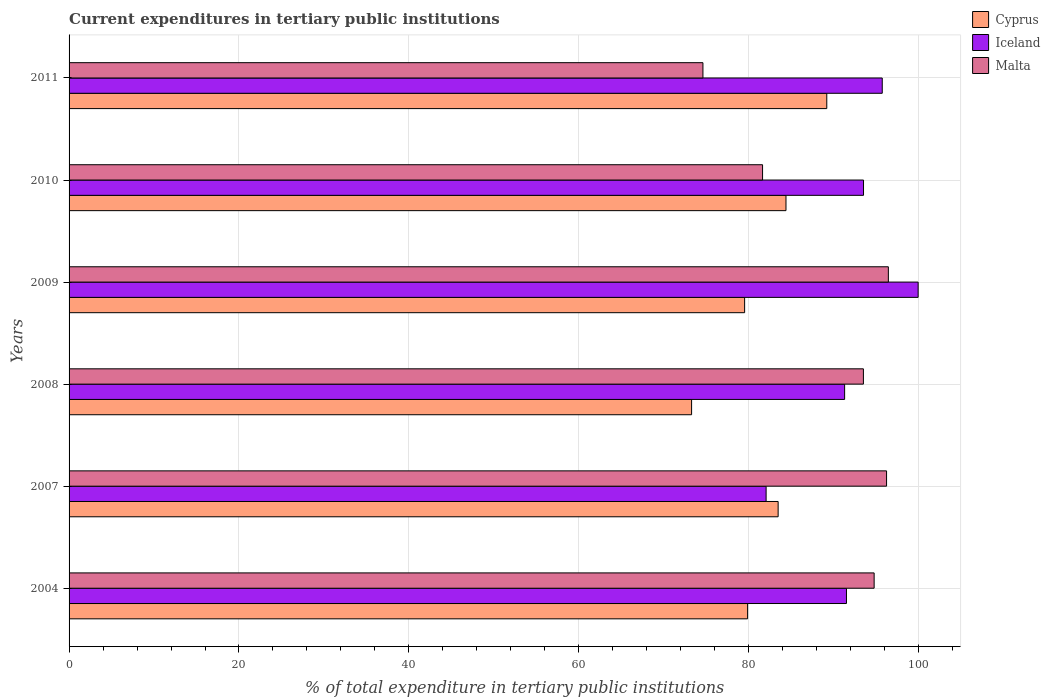How many different coloured bars are there?
Make the answer very short. 3. How many bars are there on the 1st tick from the top?
Give a very brief answer. 3. How many bars are there on the 1st tick from the bottom?
Provide a succinct answer. 3. What is the current expenditures in tertiary public institutions in Malta in 2011?
Provide a succinct answer. 74.62. Across all years, what is the maximum current expenditures in tertiary public institutions in Cyprus?
Keep it short and to the point. 89.19. Across all years, what is the minimum current expenditures in tertiary public institutions in Malta?
Provide a short and direct response. 74.62. In which year was the current expenditures in tertiary public institutions in Iceland minimum?
Make the answer very short. 2007. What is the total current expenditures in tertiary public institutions in Malta in the graph?
Provide a short and direct response. 537.19. What is the difference between the current expenditures in tertiary public institutions in Cyprus in 2008 and that in 2009?
Provide a succinct answer. -6.24. What is the difference between the current expenditures in tertiary public institutions in Malta in 2004 and the current expenditures in tertiary public institutions in Iceland in 2011?
Provide a short and direct response. -0.95. What is the average current expenditures in tertiary public institutions in Cyprus per year?
Your response must be concise. 81.62. In the year 2010, what is the difference between the current expenditures in tertiary public institutions in Malta and current expenditures in tertiary public institutions in Iceland?
Provide a succinct answer. -11.88. In how many years, is the current expenditures in tertiary public institutions in Cyprus greater than 72 %?
Provide a succinct answer. 6. What is the ratio of the current expenditures in tertiary public institutions in Malta in 2004 to that in 2011?
Give a very brief answer. 1.27. Is the difference between the current expenditures in tertiary public institutions in Malta in 2004 and 2008 greater than the difference between the current expenditures in tertiary public institutions in Iceland in 2004 and 2008?
Your answer should be compact. Yes. What is the difference between the highest and the second highest current expenditures in tertiary public institutions in Iceland?
Your answer should be very brief. 4.22. What is the difference between the highest and the lowest current expenditures in tertiary public institutions in Cyprus?
Offer a terse response. 15.91. Is the sum of the current expenditures in tertiary public institutions in Iceland in 2008 and 2011 greater than the maximum current expenditures in tertiary public institutions in Cyprus across all years?
Your response must be concise. Yes. What does the 3rd bar from the top in 2004 represents?
Provide a succinct answer. Cyprus. What does the 3rd bar from the bottom in 2008 represents?
Offer a terse response. Malta. Is it the case that in every year, the sum of the current expenditures in tertiary public institutions in Cyprus and current expenditures in tertiary public institutions in Malta is greater than the current expenditures in tertiary public institutions in Iceland?
Ensure brevity in your answer.  Yes. How many bars are there?
Provide a succinct answer. 18. Does the graph contain grids?
Keep it short and to the point. Yes. Where does the legend appear in the graph?
Offer a terse response. Top right. What is the title of the graph?
Your answer should be very brief. Current expenditures in tertiary public institutions. Does "Afghanistan" appear as one of the legend labels in the graph?
Provide a succinct answer. No. What is the label or title of the X-axis?
Make the answer very short. % of total expenditure in tertiary public institutions. What is the label or title of the Y-axis?
Provide a short and direct response. Years. What is the % of total expenditure in tertiary public institutions in Cyprus in 2004?
Your response must be concise. 79.87. What is the % of total expenditure in tertiary public institutions in Iceland in 2004?
Offer a very short reply. 91.51. What is the % of total expenditure in tertiary public institutions in Malta in 2004?
Ensure brevity in your answer.  94.77. What is the % of total expenditure in tertiary public institutions of Cyprus in 2007?
Your answer should be very brief. 83.47. What is the % of total expenditure in tertiary public institutions of Iceland in 2007?
Your answer should be very brief. 82.05. What is the % of total expenditure in tertiary public institutions of Malta in 2007?
Offer a terse response. 96.23. What is the % of total expenditure in tertiary public institutions of Cyprus in 2008?
Give a very brief answer. 73.28. What is the % of total expenditure in tertiary public institutions in Iceland in 2008?
Offer a terse response. 91.29. What is the % of total expenditure in tertiary public institutions of Malta in 2008?
Your response must be concise. 93.5. What is the % of total expenditure in tertiary public institutions of Cyprus in 2009?
Ensure brevity in your answer.  79.52. What is the % of total expenditure in tertiary public institutions in Iceland in 2009?
Provide a succinct answer. 99.95. What is the % of total expenditure in tertiary public institutions of Malta in 2009?
Your answer should be compact. 96.44. What is the % of total expenditure in tertiary public institutions in Cyprus in 2010?
Provide a short and direct response. 84.39. What is the % of total expenditure in tertiary public institutions of Iceland in 2010?
Ensure brevity in your answer.  93.52. What is the % of total expenditure in tertiary public institutions in Malta in 2010?
Your answer should be compact. 81.63. What is the % of total expenditure in tertiary public institutions of Cyprus in 2011?
Offer a terse response. 89.19. What is the % of total expenditure in tertiary public institutions of Iceland in 2011?
Provide a succinct answer. 95.72. What is the % of total expenditure in tertiary public institutions of Malta in 2011?
Keep it short and to the point. 74.62. Across all years, what is the maximum % of total expenditure in tertiary public institutions in Cyprus?
Make the answer very short. 89.19. Across all years, what is the maximum % of total expenditure in tertiary public institutions in Iceland?
Your answer should be compact. 99.95. Across all years, what is the maximum % of total expenditure in tertiary public institutions in Malta?
Offer a terse response. 96.44. Across all years, what is the minimum % of total expenditure in tertiary public institutions in Cyprus?
Offer a terse response. 73.28. Across all years, what is the minimum % of total expenditure in tertiary public institutions of Iceland?
Offer a terse response. 82.05. Across all years, what is the minimum % of total expenditure in tertiary public institutions in Malta?
Offer a terse response. 74.62. What is the total % of total expenditure in tertiary public institutions in Cyprus in the graph?
Keep it short and to the point. 489.72. What is the total % of total expenditure in tertiary public institutions in Iceland in the graph?
Keep it short and to the point. 554.04. What is the total % of total expenditure in tertiary public institutions in Malta in the graph?
Your answer should be very brief. 537.19. What is the difference between the % of total expenditure in tertiary public institutions of Cyprus in 2004 and that in 2007?
Your answer should be compact. -3.6. What is the difference between the % of total expenditure in tertiary public institutions of Iceland in 2004 and that in 2007?
Your response must be concise. 9.46. What is the difference between the % of total expenditure in tertiary public institutions in Malta in 2004 and that in 2007?
Give a very brief answer. -1.46. What is the difference between the % of total expenditure in tertiary public institutions of Cyprus in 2004 and that in 2008?
Offer a terse response. 6.59. What is the difference between the % of total expenditure in tertiary public institutions of Iceland in 2004 and that in 2008?
Give a very brief answer. 0.22. What is the difference between the % of total expenditure in tertiary public institutions of Malta in 2004 and that in 2008?
Give a very brief answer. 1.26. What is the difference between the % of total expenditure in tertiary public institutions in Cyprus in 2004 and that in 2009?
Your answer should be very brief. 0.35. What is the difference between the % of total expenditure in tertiary public institutions of Iceland in 2004 and that in 2009?
Your answer should be very brief. -8.44. What is the difference between the % of total expenditure in tertiary public institutions in Malta in 2004 and that in 2009?
Provide a short and direct response. -1.67. What is the difference between the % of total expenditure in tertiary public institutions in Cyprus in 2004 and that in 2010?
Keep it short and to the point. -4.52. What is the difference between the % of total expenditure in tertiary public institutions in Iceland in 2004 and that in 2010?
Give a very brief answer. -2.01. What is the difference between the % of total expenditure in tertiary public institutions in Malta in 2004 and that in 2010?
Your answer should be compact. 13.13. What is the difference between the % of total expenditure in tertiary public institutions of Cyprus in 2004 and that in 2011?
Provide a succinct answer. -9.32. What is the difference between the % of total expenditure in tertiary public institutions in Iceland in 2004 and that in 2011?
Provide a short and direct response. -4.21. What is the difference between the % of total expenditure in tertiary public institutions in Malta in 2004 and that in 2011?
Provide a short and direct response. 20.15. What is the difference between the % of total expenditure in tertiary public institutions of Cyprus in 2007 and that in 2008?
Ensure brevity in your answer.  10.19. What is the difference between the % of total expenditure in tertiary public institutions in Iceland in 2007 and that in 2008?
Your answer should be compact. -9.24. What is the difference between the % of total expenditure in tertiary public institutions in Malta in 2007 and that in 2008?
Your answer should be compact. 2.73. What is the difference between the % of total expenditure in tertiary public institutions of Cyprus in 2007 and that in 2009?
Offer a terse response. 3.95. What is the difference between the % of total expenditure in tertiary public institutions in Iceland in 2007 and that in 2009?
Your response must be concise. -17.89. What is the difference between the % of total expenditure in tertiary public institutions of Malta in 2007 and that in 2009?
Offer a very short reply. -0.21. What is the difference between the % of total expenditure in tertiary public institutions in Cyprus in 2007 and that in 2010?
Your answer should be compact. -0.92. What is the difference between the % of total expenditure in tertiary public institutions in Iceland in 2007 and that in 2010?
Keep it short and to the point. -11.47. What is the difference between the % of total expenditure in tertiary public institutions in Malta in 2007 and that in 2010?
Make the answer very short. 14.6. What is the difference between the % of total expenditure in tertiary public institutions in Cyprus in 2007 and that in 2011?
Keep it short and to the point. -5.73. What is the difference between the % of total expenditure in tertiary public institutions of Iceland in 2007 and that in 2011?
Your answer should be very brief. -13.67. What is the difference between the % of total expenditure in tertiary public institutions of Malta in 2007 and that in 2011?
Your answer should be very brief. 21.62. What is the difference between the % of total expenditure in tertiary public institutions of Cyprus in 2008 and that in 2009?
Give a very brief answer. -6.24. What is the difference between the % of total expenditure in tertiary public institutions of Iceland in 2008 and that in 2009?
Give a very brief answer. -8.65. What is the difference between the % of total expenditure in tertiary public institutions in Malta in 2008 and that in 2009?
Offer a terse response. -2.94. What is the difference between the % of total expenditure in tertiary public institutions of Cyprus in 2008 and that in 2010?
Make the answer very short. -11.11. What is the difference between the % of total expenditure in tertiary public institutions in Iceland in 2008 and that in 2010?
Ensure brevity in your answer.  -2.22. What is the difference between the % of total expenditure in tertiary public institutions in Malta in 2008 and that in 2010?
Your answer should be very brief. 11.87. What is the difference between the % of total expenditure in tertiary public institutions of Cyprus in 2008 and that in 2011?
Offer a terse response. -15.91. What is the difference between the % of total expenditure in tertiary public institutions of Iceland in 2008 and that in 2011?
Ensure brevity in your answer.  -4.43. What is the difference between the % of total expenditure in tertiary public institutions in Malta in 2008 and that in 2011?
Your answer should be very brief. 18.89. What is the difference between the % of total expenditure in tertiary public institutions in Cyprus in 2009 and that in 2010?
Ensure brevity in your answer.  -4.87. What is the difference between the % of total expenditure in tertiary public institutions in Iceland in 2009 and that in 2010?
Your response must be concise. 6.43. What is the difference between the % of total expenditure in tertiary public institutions of Malta in 2009 and that in 2010?
Give a very brief answer. 14.81. What is the difference between the % of total expenditure in tertiary public institutions in Cyprus in 2009 and that in 2011?
Give a very brief answer. -9.67. What is the difference between the % of total expenditure in tertiary public institutions of Iceland in 2009 and that in 2011?
Your answer should be very brief. 4.22. What is the difference between the % of total expenditure in tertiary public institutions of Malta in 2009 and that in 2011?
Keep it short and to the point. 21.83. What is the difference between the % of total expenditure in tertiary public institutions of Cyprus in 2010 and that in 2011?
Offer a terse response. -4.8. What is the difference between the % of total expenditure in tertiary public institutions in Iceland in 2010 and that in 2011?
Provide a succinct answer. -2.21. What is the difference between the % of total expenditure in tertiary public institutions of Malta in 2010 and that in 2011?
Make the answer very short. 7.02. What is the difference between the % of total expenditure in tertiary public institutions in Cyprus in 2004 and the % of total expenditure in tertiary public institutions in Iceland in 2007?
Your response must be concise. -2.18. What is the difference between the % of total expenditure in tertiary public institutions of Cyprus in 2004 and the % of total expenditure in tertiary public institutions of Malta in 2007?
Offer a terse response. -16.36. What is the difference between the % of total expenditure in tertiary public institutions of Iceland in 2004 and the % of total expenditure in tertiary public institutions of Malta in 2007?
Ensure brevity in your answer.  -4.72. What is the difference between the % of total expenditure in tertiary public institutions in Cyprus in 2004 and the % of total expenditure in tertiary public institutions in Iceland in 2008?
Your response must be concise. -11.42. What is the difference between the % of total expenditure in tertiary public institutions in Cyprus in 2004 and the % of total expenditure in tertiary public institutions in Malta in 2008?
Your answer should be very brief. -13.63. What is the difference between the % of total expenditure in tertiary public institutions of Iceland in 2004 and the % of total expenditure in tertiary public institutions of Malta in 2008?
Your answer should be very brief. -1.99. What is the difference between the % of total expenditure in tertiary public institutions of Cyprus in 2004 and the % of total expenditure in tertiary public institutions of Iceland in 2009?
Keep it short and to the point. -20.07. What is the difference between the % of total expenditure in tertiary public institutions of Cyprus in 2004 and the % of total expenditure in tertiary public institutions of Malta in 2009?
Offer a terse response. -16.57. What is the difference between the % of total expenditure in tertiary public institutions of Iceland in 2004 and the % of total expenditure in tertiary public institutions of Malta in 2009?
Your answer should be compact. -4.93. What is the difference between the % of total expenditure in tertiary public institutions of Cyprus in 2004 and the % of total expenditure in tertiary public institutions of Iceland in 2010?
Your answer should be compact. -13.65. What is the difference between the % of total expenditure in tertiary public institutions in Cyprus in 2004 and the % of total expenditure in tertiary public institutions in Malta in 2010?
Give a very brief answer. -1.76. What is the difference between the % of total expenditure in tertiary public institutions in Iceland in 2004 and the % of total expenditure in tertiary public institutions in Malta in 2010?
Offer a very short reply. 9.88. What is the difference between the % of total expenditure in tertiary public institutions of Cyprus in 2004 and the % of total expenditure in tertiary public institutions of Iceland in 2011?
Offer a very short reply. -15.85. What is the difference between the % of total expenditure in tertiary public institutions in Cyprus in 2004 and the % of total expenditure in tertiary public institutions in Malta in 2011?
Your response must be concise. 5.26. What is the difference between the % of total expenditure in tertiary public institutions of Iceland in 2004 and the % of total expenditure in tertiary public institutions of Malta in 2011?
Offer a terse response. 16.9. What is the difference between the % of total expenditure in tertiary public institutions in Cyprus in 2007 and the % of total expenditure in tertiary public institutions in Iceland in 2008?
Your response must be concise. -7.83. What is the difference between the % of total expenditure in tertiary public institutions of Cyprus in 2007 and the % of total expenditure in tertiary public institutions of Malta in 2008?
Your response must be concise. -10.04. What is the difference between the % of total expenditure in tertiary public institutions in Iceland in 2007 and the % of total expenditure in tertiary public institutions in Malta in 2008?
Ensure brevity in your answer.  -11.45. What is the difference between the % of total expenditure in tertiary public institutions of Cyprus in 2007 and the % of total expenditure in tertiary public institutions of Iceland in 2009?
Provide a short and direct response. -16.48. What is the difference between the % of total expenditure in tertiary public institutions of Cyprus in 2007 and the % of total expenditure in tertiary public institutions of Malta in 2009?
Provide a short and direct response. -12.97. What is the difference between the % of total expenditure in tertiary public institutions in Iceland in 2007 and the % of total expenditure in tertiary public institutions in Malta in 2009?
Keep it short and to the point. -14.39. What is the difference between the % of total expenditure in tertiary public institutions of Cyprus in 2007 and the % of total expenditure in tertiary public institutions of Iceland in 2010?
Provide a succinct answer. -10.05. What is the difference between the % of total expenditure in tertiary public institutions of Cyprus in 2007 and the % of total expenditure in tertiary public institutions of Malta in 2010?
Your response must be concise. 1.83. What is the difference between the % of total expenditure in tertiary public institutions of Iceland in 2007 and the % of total expenditure in tertiary public institutions of Malta in 2010?
Give a very brief answer. 0.42. What is the difference between the % of total expenditure in tertiary public institutions of Cyprus in 2007 and the % of total expenditure in tertiary public institutions of Iceland in 2011?
Make the answer very short. -12.25. What is the difference between the % of total expenditure in tertiary public institutions of Cyprus in 2007 and the % of total expenditure in tertiary public institutions of Malta in 2011?
Keep it short and to the point. 8.85. What is the difference between the % of total expenditure in tertiary public institutions in Iceland in 2007 and the % of total expenditure in tertiary public institutions in Malta in 2011?
Make the answer very short. 7.44. What is the difference between the % of total expenditure in tertiary public institutions of Cyprus in 2008 and the % of total expenditure in tertiary public institutions of Iceland in 2009?
Your answer should be very brief. -26.67. What is the difference between the % of total expenditure in tertiary public institutions in Cyprus in 2008 and the % of total expenditure in tertiary public institutions in Malta in 2009?
Provide a short and direct response. -23.16. What is the difference between the % of total expenditure in tertiary public institutions of Iceland in 2008 and the % of total expenditure in tertiary public institutions of Malta in 2009?
Keep it short and to the point. -5.15. What is the difference between the % of total expenditure in tertiary public institutions of Cyprus in 2008 and the % of total expenditure in tertiary public institutions of Iceland in 2010?
Your answer should be very brief. -20.24. What is the difference between the % of total expenditure in tertiary public institutions in Cyprus in 2008 and the % of total expenditure in tertiary public institutions in Malta in 2010?
Your answer should be compact. -8.35. What is the difference between the % of total expenditure in tertiary public institutions of Iceland in 2008 and the % of total expenditure in tertiary public institutions of Malta in 2010?
Keep it short and to the point. 9.66. What is the difference between the % of total expenditure in tertiary public institutions of Cyprus in 2008 and the % of total expenditure in tertiary public institutions of Iceland in 2011?
Give a very brief answer. -22.44. What is the difference between the % of total expenditure in tertiary public institutions in Cyprus in 2008 and the % of total expenditure in tertiary public institutions in Malta in 2011?
Give a very brief answer. -1.34. What is the difference between the % of total expenditure in tertiary public institutions of Iceland in 2008 and the % of total expenditure in tertiary public institutions of Malta in 2011?
Make the answer very short. 16.68. What is the difference between the % of total expenditure in tertiary public institutions of Cyprus in 2009 and the % of total expenditure in tertiary public institutions of Iceland in 2010?
Provide a short and direct response. -14. What is the difference between the % of total expenditure in tertiary public institutions of Cyprus in 2009 and the % of total expenditure in tertiary public institutions of Malta in 2010?
Provide a short and direct response. -2.11. What is the difference between the % of total expenditure in tertiary public institutions of Iceland in 2009 and the % of total expenditure in tertiary public institutions of Malta in 2010?
Offer a very short reply. 18.31. What is the difference between the % of total expenditure in tertiary public institutions of Cyprus in 2009 and the % of total expenditure in tertiary public institutions of Iceland in 2011?
Make the answer very short. -16.2. What is the difference between the % of total expenditure in tertiary public institutions in Cyprus in 2009 and the % of total expenditure in tertiary public institutions in Malta in 2011?
Offer a terse response. 4.91. What is the difference between the % of total expenditure in tertiary public institutions of Iceland in 2009 and the % of total expenditure in tertiary public institutions of Malta in 2011?
Make the answer very short. 25.33. What is the difference between the % of total expenditure in tertiary public institutions of Cyprus in 2010 and the % of total expenditure in tertiary public institutions of Iceland in 2011?
Your response must be concise. -11.33. What is the difference between the % of total expenditure in tertiary public institutions in Cyprus in 2010 and the % of total expenditure in tertiary public institutions in Malta in 2011?
Offer a very short reply. 9.78. What is the difference between the % of total expenditure in tertiary public institutions of Iceland in 2010 and the % of total expenditure in tertiary public institutions of Malta in 2011?
Provide a short and direct response. 18.9. What is the average % of total expenditure in tertiary public institutions of Cyprus per year?
Offer a very short reply. 81.62. What is the average % of total expenditure in tertiary public institutions in Iceland per year?
Offer a terse response. 92.34. What is the average % of total expenditure in tertiary public institutions in Malta per year?
Provide a short and direct response. 89.53. In the year 2004, what is the difference between the % of total expenditure in tertiary public institutions of Cyprus and % of total expenditure in tertiary public institutions of Iceland?
Your answer should be very brief. -11.64. In the year 2004, what is the difference between the % of total expenditure in tertiary public institutions of Cyprus and % of total expenditure in tertiary public institutions of Malta?
Keep it short and to the point. -14.9. In the year 2004, what is the difference between the % of total expenditure in tertiary public institutions of Iceland and % of total expenditure in tertiary public institutions of Malta?
Your response must be concise. -3.26. In the year 2007, what is the difference between the % of total expenditure in tertiary public institutions of Cyprus and % of total expenditure in tertiary public institutions of Iceland?
Your response must be concise. 1.42. In the year 2007, what is the difference between the % of total expenditure in tertiary public institutions in Cyprus and % of total expenditure in tertiary public institutions in Malta?
Your response must be concise. -12.76. In the year 2007, what is the difference between the % of total expenditure in tertiary public institutions of Iceland and % of total expenditure in tertiary public institutions of Malta?
Offer a very short reply. -14.18. In the year 2008, what is the difference between the % of total expenditure in tertiary public institutions in Cyprus and % of total expenditure in tertiary public institutions in Iceland?
Give a very brief answer. -18.01. In the year 2008, what is the difference between the % of total expenditure in tertiary public institutions of Cyprus and % of total expenditure in tertiary public institutions of Malta?
Your response must be concise. -20.22. In the year 2008, what is the difference between the % of total expenditure in tertiary public institutions of Iceland and % of total expenditure in tertiary public institutions of Malta?
Your answer should be compact. -2.21. In the year 2009, what is the difference between the % of total expenditure in tertiary public institutions in Cyprus and % of total expenditure in tertiary public institutions in Iceland?
Give a very brief answer. -20.42. In the year 2009, what is the difference between the % of total expenditure in tertiary public institutions of Cyprus and % of total expenditure in tertiary public institutions of Malta?
Keep it short and to the point. -16.92. In the year 2009, what is the difference between the % of total expenditure in tertiary public institutions of Iceland and % of total expenditure in tertiary public institutions of Malta?
Make the answer very short. 3.51. In the year 2010, what is the difference between the % of total expenditure in tertiary public institutions in Cyprus and % of total expenditure in tertiary public institutions in Iceland?
Provide a succinct answer. -9.13. In the year 2010, what is the difference between the % of total expenditure in tertiary public institutions in Cyprus and % of total expenditure in tertiary public institutions in Malta?
Give a very brief answer. 2.76. In the year 2010, what is the difference between the % of total expenditure in tertiary public institutions of Iceland and % of total expenditure in tertiary public institutions of Malta?
Provide a short and direct response. 11.88. In the year 2011, what is the difference between the % of total expenditure in tertiary public institutions of Cyprus and % of total expenditure in tertiary public institutions of Iceland?
Provide a succinct answer. -6.53. In the year 2011, what is the difference between the % of total expenditure in tertiary public institutions in Cyprus and % of total expenditure in tertiary public institutions in Malta?
Offer a terse response. 14.58. In the year 2011, what is the difference between the % of total expenditure in tertiary public institutions of Iceland and % of total expenditure in tertiary public institutions of Malta?
Your response must be concise. 21.11. What is the ratio of the % of total expenditure in tertiary public institutions in Cyprus in 2004 to that in 2007?
Give a very brief answer. 0.96. What is the ratio of the % of total expenditure in tertiary public institutions of Iceland in 2004 to that in 2007?
Your answer should be very brief. 1.12. What is the ratio of the % of total expenditure in tertiary public institutions in Cyprus in 2004 to that in 2008?
Keep it short and to the point. 1.09. What is the ratio of the % of total expenditure in tertiary public institutions of Malta in 2004 to that in 2008?
Make the answer very short. 1.01. What is the ratio of the % of total expenditure in tertiary public institutions in Cyprus in 2004 to that in 2009?
Your answer should be very brief. 1. What is the ratio of the % of total expenditure in tertiary public institutions in Iceland in 2004 to that in 2009?
Your answer should be very brief. 0.92. What is the ratio of the % of total expenditure in tertiary public institutions of Malta in 2004 to that in 2009?
Give a very brief answer. 0.98. What is the ratio of the % of total expenditure in tertiary public institutions in Cyprus in 2004 to that in 2010?
Ensure brevity in your answer.  0.95. What is the ratio of the % of total expenditure in tertiary public institutions in Iceland in 2004 to that in 2010?
Make the answer very short. 0.98. What is the ratio of the % of total expenditure in tertiary public institutions in Malta in 2004 to that in 2010?
Make the answer very short. 1.16. What is the ratio of the % of total expenditure in tertiary public institutions in Cyprus in 2004 to that in 2011?
Make the answer very short. 0.9. What is the ratio of the % of total expenditure in tertiary public institutions in Iceland in 2004 to that in 2011?
Offer a terse response. 0.96. What is the ratio of the % of total expenditure in tertiary public institutions of Malta in 2004 to that in 2011?
Provide a succinct answer. 1.27. What is the ratio of the % of total expenditure in tertiary public institutions of Cyprus in 2007 to that in 2008?
Offer a terse response. 1.14. What is the ratio of the % of total expenditure in tertiary public institutions in Iceland in 2007 to that in 2008?
Your answer should be compact. 0.9. What is the ratio of the % of total expenditure in tertiary public institutions of Malta in 2007 to that in 2008?
Keep it short and to the point. 1.03. What is the ratio of the % of total expenditure in tertiary public institutions of Cyprus in 2007 to that in 2009?
Make the answer very short. 1.05. What is the ratio of the % of total expenditure in tertiary public institutions of Iceland in 2007 to that in 2009?
Ensure brevity in your answer.  0.82. What is the ratio of the % of total expenditure in tertiary public institutions of Malta in 2007 to that in 2009?
Your response must be concise. 1. What is the ratio of the % of total expenditure in tertiary public institutions in Iceland in 2007 to that in 2010?
Your response must be concise. 0.88. What is the ratio of the % of total expenditure in tertiary public institutions of Malta in 2007 to that in 2010?
Offer a terse response. 1.18. What is the ratio of the % of total expenditure in tertiary public institutions in Cyprus in 2007 to that in 2011?
Your answer should be very brief. 0.94. What is the ratio of the % of total expenditure in tertiary public institutions in Iceland in 2007 to that in 2011?
Keep it short and to the point. 0.86. What is the ratio of the % of total expenditure in tertiary public institutions in Malta in 2007 to that in 2011?
Give a very brief answer. 1.29. What is the ratio of the % of total expenditure in tertiary public institutions of Cyprus in 2008 to that in 2009?
Your answer should be very brief. 0.92. What is the ratio of the % of total expenditure in tertiary public institutions in Iceland in 2008 to that in 2009?
Provide a short and direct response. 0.91. What is the ratio of the % of total expenditure in tertiary public institutions of Malta in 2008 to that in 2009?
Your answer should be very brief. 0.97. What is the ratio of the % of total expenditure in tertiary public institutions in Cyprus in 2008 to that in 2010?
Make the answer very short. 0.87. What is the ratio of the % of total expenditure in tertiary public institutions of Iceland in 2008 to that in 2010?
Your answer should be compact. 0.98. What is the ratio of the % of total expenditure in tertiary public institutions in Malta in 2008 to that in 2010?
Provide a succinct answer. 1.15. What is the ratio of the % of total expenditure in tertiary public institutions in Cyprus in 2008 to that in 2011?
Offer a terse response. 0.82. What is the ratio of the % of total expenditure in tertiary public institutions of Iceland in 2008 to that in 2011?
Offer a very short reply. 0.95. What is the ratio of the % of total expenditure in tertiary public institutions of Malta in 2008 to that in 2011?
Your response must be concise. 1.25. What is the ratio of the % of total expenditure in tertiary public institutions of Cyprus in 2009 to that in 2010?
Offer a very short reply. 0.94. What is the ratio of the % of total expenditure in tertiary public institutions of Iceland in 2009 to that in 2010?
Your response must be concise. 1.07. What is the ratio of the % of total expenditure in tertiary public institutions of Malta in 2009 to that in 2010?
Make the answer very short. 1.18. What is the ratio of the % of total expenditure in tertiary public institutions in Cyprus in 2009 to that in 2011?
Offer a very short reply. 0.89. What is the ratio of the % of total expenditure in tertiary public institutions in Iceland in 2009 to that in 2011?
Provide a succinct answer. 1.04. What is the ratio of the % of total expenditure in tertiary public institutions in Malta in 2009 to that in 2011?
Provide a short and direct response. 1.29. What is the ratio of the % of total expenditure in tertiary public institutions of Cyprus in 2010 to that in 2011?
Give a very brief answer. 0.95. What is the ratio of the % of total expenditure in tertiary public institutions of Iceland in 2010 to that in 2011?
Provide a short and direct response. 0.98. What is the ratio of the % of total expenditure in tertiary public institutions in Malta in 2010 to that in 2011?
Keep it short and to the point. 1.09. What is the difference between the highest and the second highest % of total expenditure in tertiary public institutions in Cyprus?
Make the answer very short. 4.8. What is the difference between the highest and the second highest % of total expenditure in tertiary public institutions of Iceland?
Your answer should be very brief. 4.22. What is the difference between the highest and the second highest % of total expenditure in tertiary public institutions in Malta?
Your answer should be very brief. 0.21. What is the difference between the highest and the lowest % of total expenditure in tertiary public institutions of Cyprus?
Your answer should be compact. 15.91. What is the difference between the highest and the lowest % of total expenditure in tertiary public institutions of Iceland?
Offer a very short reply. 17.89. What is the difference between the highest and the lowest % of total expenditure in tertiary public institutions of Malta?
Your answer should be compact. 21.83. 